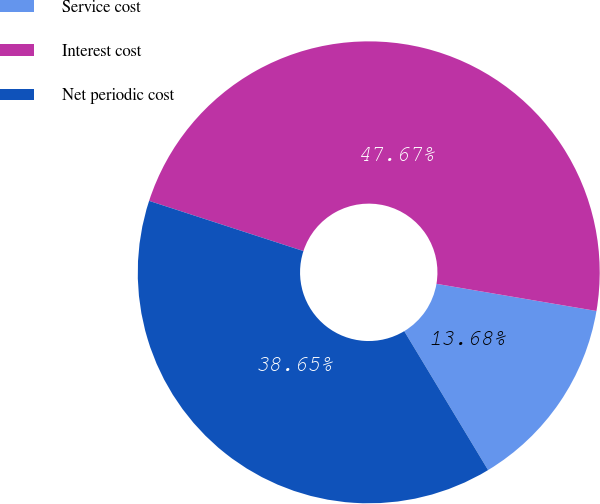<chart> <loc_0><loc_0><loc_500><loc_500><pie_chart><fcel>Service cost<fcel>Interest cost<fcel>Net periodic cost<nl><fcel>13.68%<fcel>47.67%<fcel>38.65%<nl></chart> 